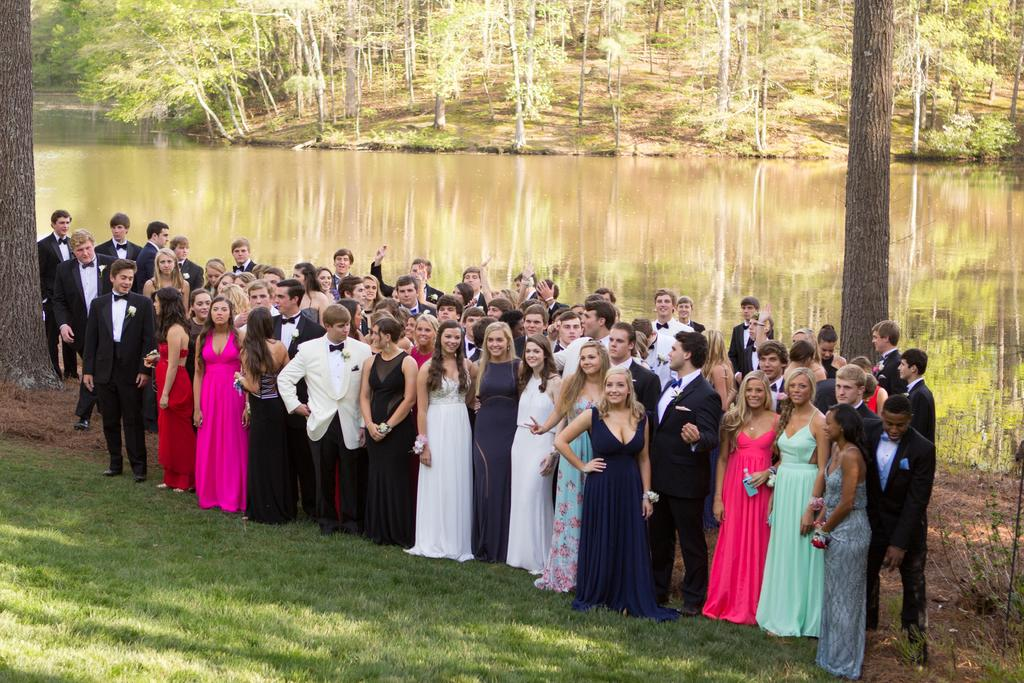How many people are in the image? There is a group of people in the image. What is the surface the people are standing on? The people are standing on the grass. What can be seen in the background of the image? There is a lake in the background of the image. What type of vegetation is present in the image? There are many trees in the image. How many bikes are parked near the group of people in the image? There are no bikes present in the image. What type of gate can be seen in the image? There is no gate present in the image. 